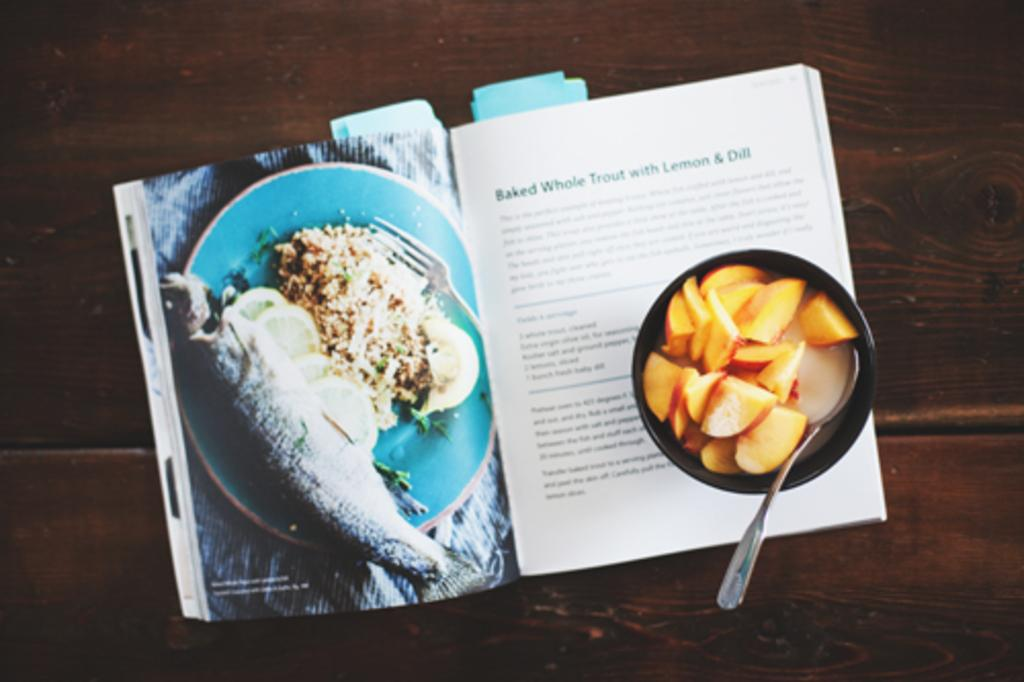<image>
Write a terse but informative summary of the picture. A book opened to a recipe for baked whole trout with lemon and dill. 